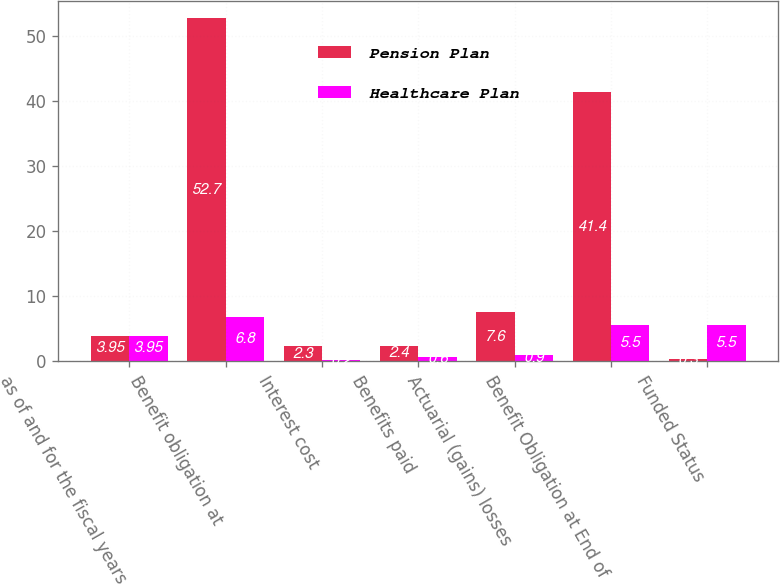Convert chart to OTSL. <chart><loc_0><loc_0><loc_500><loc_500><stacked_bar_chart><ecel><fcel>as of and for the fiscal years<fcel>Benefit obligation at<fcel>Interest cost<fcel>Benefits paid<fcel>Actuarial (gains) losses<fcel>Benefit Obligation at End of<fcel>Funded Status<nl><fcel>Pension Plan<fcel>3.95<fcel>52.7<fcel>2.3<fcel>2.4<fcel>7.6<fcel>41.4<fcel>0.3<nl><fcel>Healthcare Plan<fcel>3.95<fcel>6.8<fcel>0.2<fcel>0.6<fcel>0.9<fcel>5.5<fcel>5.5<nl></chart> 